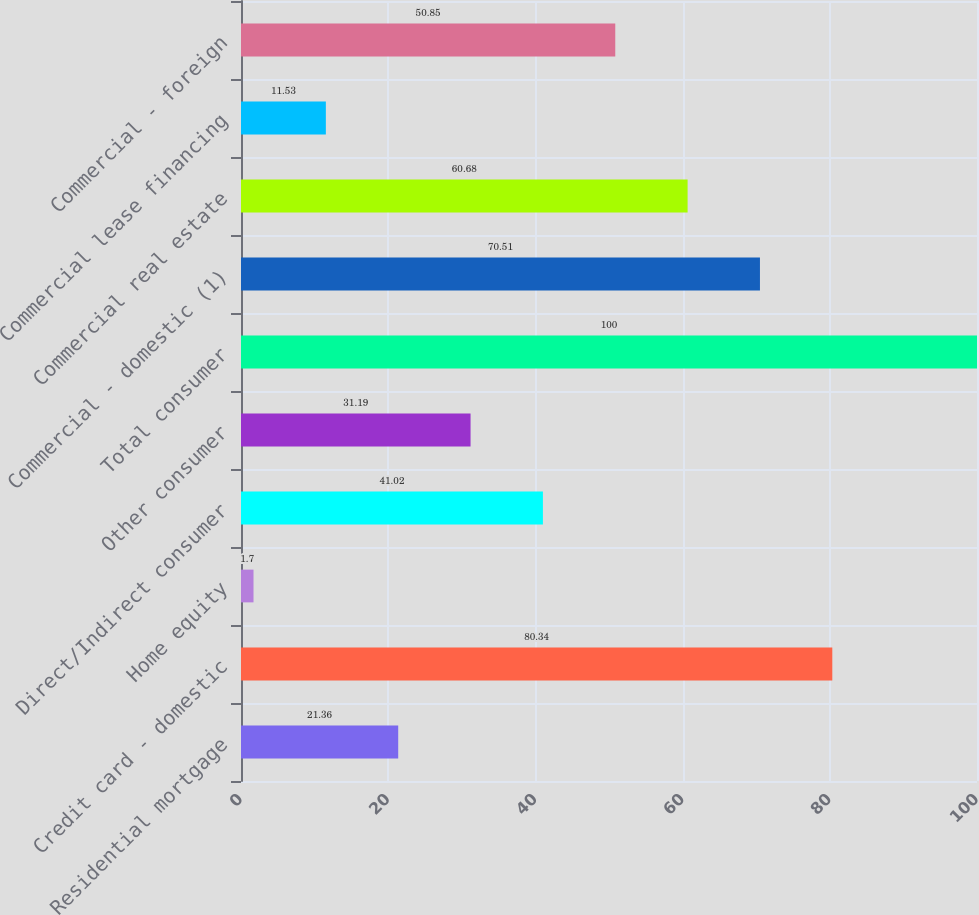<chart> <loc_0><loc_0><loc_500><loc_500><bar_chart><fcel>Residential mortgage<fcel>Credit card - domestic<fcel>Home equity<fcel>Direct/Indirect consumer<fcel>Other consumer<fcel>Total consumer<fcel>Commercial - domestic (1)<fcel>Commercial real estate<fcel>Commercial lease financing<fcel>Commercial - foreign<nl><fcel>21.36<fcel>80.34<fcel>1.7<fcel>41.02<fcel>31.19<fcel>100<fcel>70.51<fcel>60.68<fcel>11.53<fcel>50.85<nl></chart> 